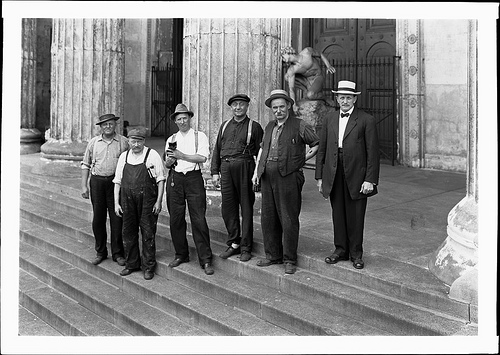<image>Where is the statue? I don't know where the statue is. It might be in the background, behind the men or right of the column. Where is the statue? It is not clear where the statue is located. 